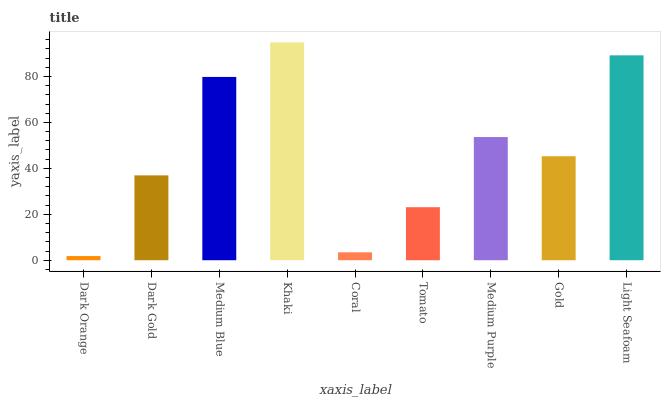Is Dark Orange the minimum?
Answer yes or no. Yes. Is Khaki the maximum?
Answer yes or no. Yes. Is Dark Gold the minimum?
Answer yes or no. No. Is Dark Gold the maximum?
Answer yes or no. No. Is Dark Gold greater than Dark Orange?
Answer yes or no. Yes. Is Dark Orange less than Dark Gold?
Answer yes or no. Yes. Is Dark Orange greater than Dark Gold?
Answer yes or no. No. Is Dark Gold less than Dark Orange?
Answer yes or no. No. Is Gold the high median?
Answer yes or no. Yes. Is Gold the low median?
Answer yes or no. Yes. Is Dark Gold the high median?
Answer yes or no. No. Is Khaki the low median?
Answer yes or no. No. 